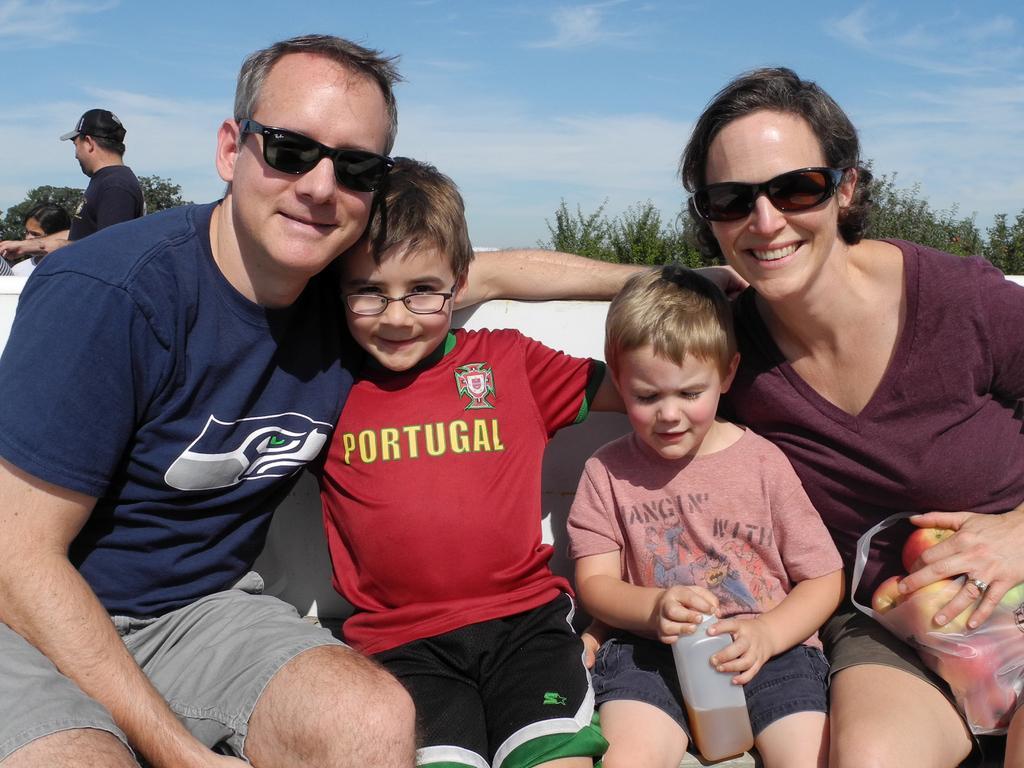How would you summarize this image in a sentence or two? In this picture I can see four persons sitting, there are some objects, there are few people standing, and in the background there are trees and there is the sky. 